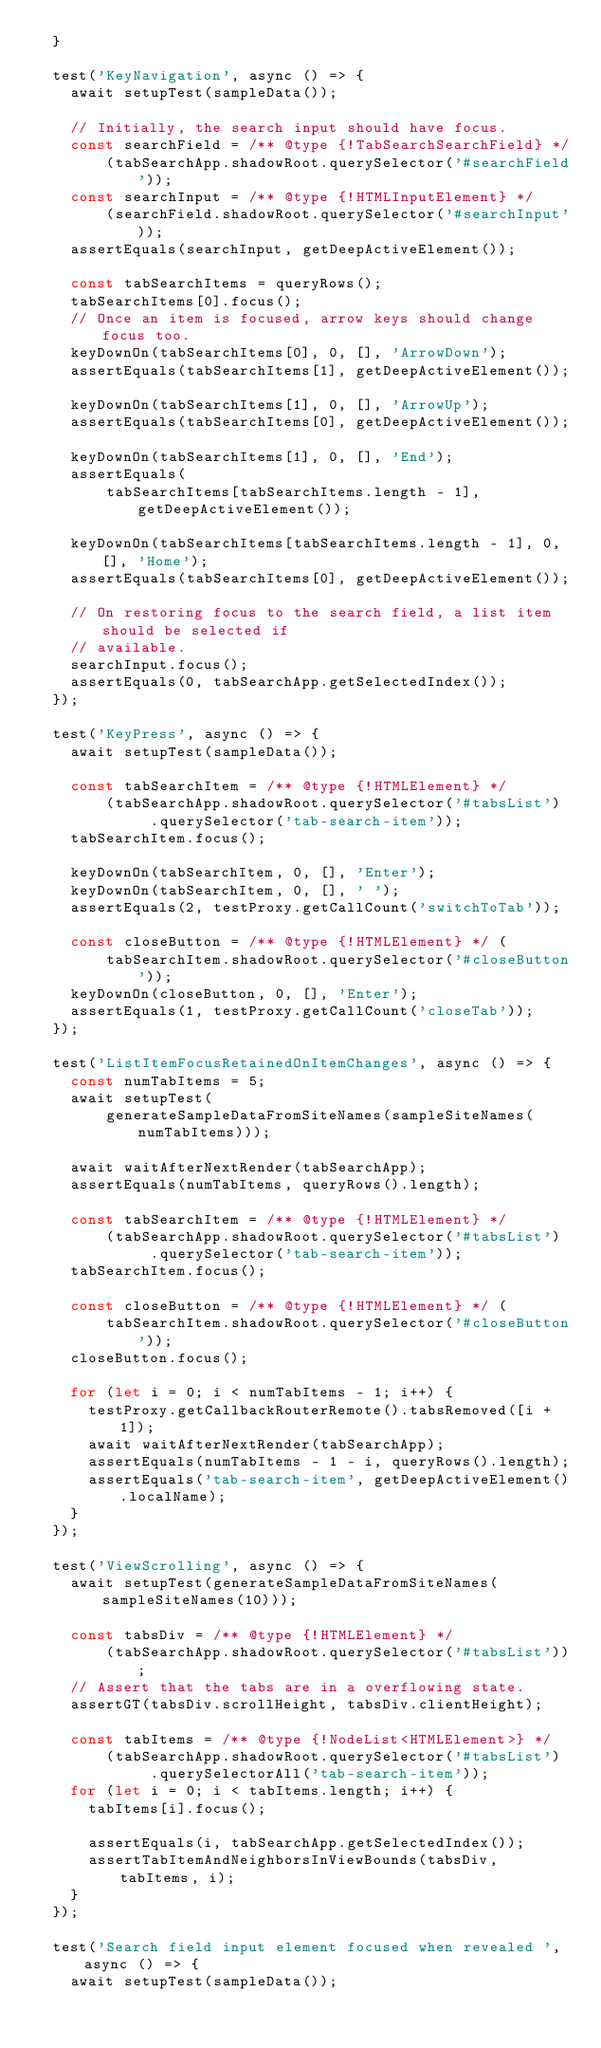Convert code to text. <code><loc_0><loc_0><loc_500><loc_500><_JavaScript_>  }

  test('KeyNavigation', async () => {
    await setupTest(sampleData());

    // Initially, the search input should have focus.
    const searchField = /** @type {!TabSearchSearchField} */
        (tabSearchApp.shadowRoot.querySelector('#searchField'));
    const searchInput = /** @type {!HTMLInputElement} */
        (searchField.shadowRoot.querySelector('#searchInput'));
    assertEquals(searchInput, getDeepActiveElement());

    const tabSearchItems = queryRows();
    tabSearchItems[0].focus();
    // Once an item is focused, arrow keys should change focus too.
    keyDownOn(tabSearchItems[0], 0, [], 'ArrowDown');
    assertEquals(tabSearchItems[1], getDeepActiveElement());

    keyDownOn(tabSearchItems[1], 0, [], 'ArrowUp');
    assertEquals(tabSearchItems[0], getDeepActiveElement());

    keyDownOn(tabSearchItems[1], 0, [], 'End');
    assertEquals(
        tabSearchItems[tabSearchItems.length - 1], getDeepActiveElement());

    keyDownOn(tabSearchItems[tabSearchItems.length - 1], 0, [], 'Home');
    assertEquals(tabSearchItems[0], getDeepActiveElement());

    // On restoring focus to the search field, a list item should be selected if
    // available.
    searchInput.focus();
    assertEquals(0, tabSearchApp.getSelectedIndex());
  });

  test('KeyPress', async () => {
    await setupTest(sampleData());

    const tabSearchItem = /** @type {!HTMLElement} */
        (tabSearchApp.shadowRoot.querySelector('#tabsList')
             .querySelector('tab-search-item'));
    tabSearchItem.focus();

    keyDownOn(tabSearchItem, 0, [], 'Enter');
    keyDownOn(tabSearchItem, 0, [], ' ');
    assertEquals(2, testProxy.getCallCount('switchToTab'));

    const closeButton = /** @type {!HTMLElement} */ (
        tabSearchItem.shadowRoot.querySelector('#closeButton'));
    keyDownOn(closeButton, 0, [], 'Enter');
    assertEquals(1, testProxy.getCallCount('closeTab'));
  });

  test('ListItemFocusRetainedOnItemChanges', async () => {
    const numTabItems = 5;
    await setupTest(
        generateSampleDataFromSiteNames(sampleSiteNames(numTabItems)));

    await waitAfterNextRender(tabSearchApp);
    assertEquals(numTabItems, queryRows().length);

    const tabSearchItem = /** @type {!HTMLElement} */
        (tabSearchApp.shadowRoot.querySelector('#tabsList')
             .querySelector('tab-search-item'));
    tabSearchItem.focus();

    const closeButton = /** @type {!HTMLElement} */ (
        tabSearchItem.shadowRoot.querySelector('#closeButton'));
    closeButton.focus();

    for (let i = 0; i < numTabItems - 1; i++) {
      testProxy.getCallbackRouterRemote().tabsRemoved([i + 1]);
      await waitAfterNextRender(tabSearchApp);
      assertEquals(numTabItems - 1 - i, queryRows().length);
      assertEquals('tab-search-item', getDeepActiveElement().localName);
    }
  });

  test('ViewScrolling', async () => {
    await setupTest(generateSampleDataFromSiteNames(sampleSiteNames(10)));

    const tabsDiv = /** @type {!HTMLElement} */
        (tabSearchApp.shadowRoot.querySelector('#tabsList'));
    // Assert that the tabs are in a overflowing state.
    assertGT(tabsDiv.scrollHeight, tabsDiv.clientHeight);

    const tabItems = /** @type {!NodeList<HTMLElement>} */
        (tabSearchApp.shadowRoot.querySelector('#tabsList')
             .querySelectorAll('tab-search-item'));
    for (let i = 0; i < tabItems.length; i++) {
      tabItems[i].focus();

      assertEquals(i, tabSearchApp.getSelectedIndex());
      assertTabItemAndNeighborsInViewBounds(tabsDiv, tabItems, i);
    }
  });

  test('Search field input element focused when revealed ', async () => {
    await setupTest(sampleData());
</code> 